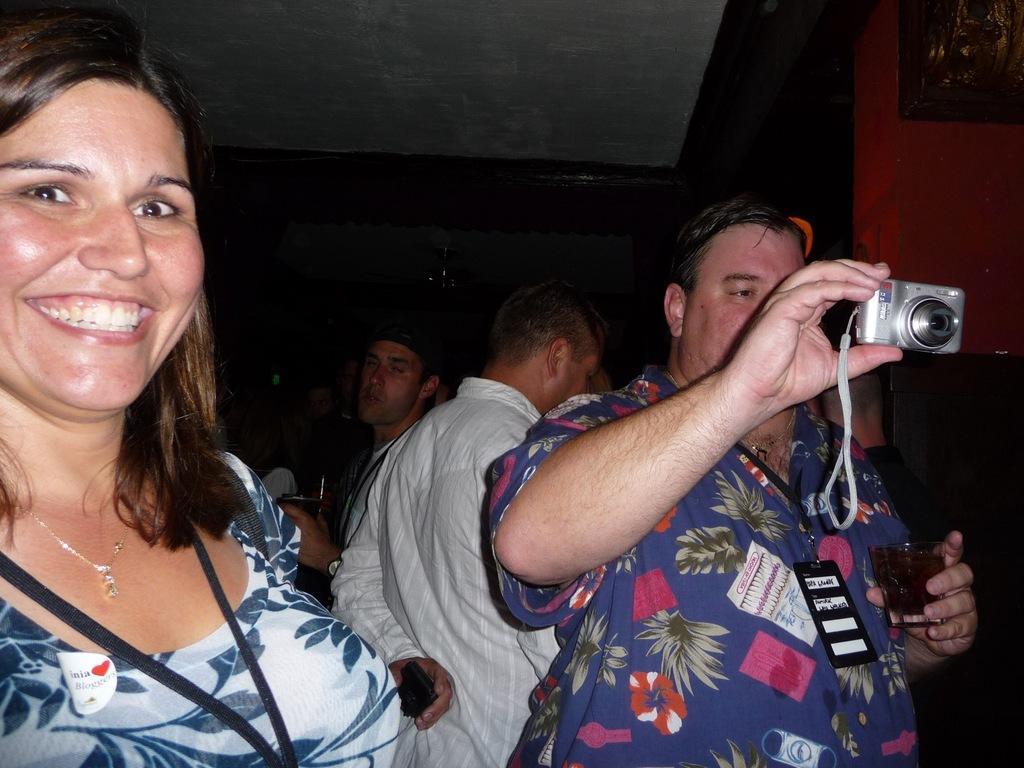Could you give a brief overview of what you see in this image? In this picture there are few people who are standing. There is a man holding a camera in his hand. 